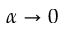<formula> <loc_0><loc_0><loc_500><loc_500>\alpha \rightarrow 0</formula> 